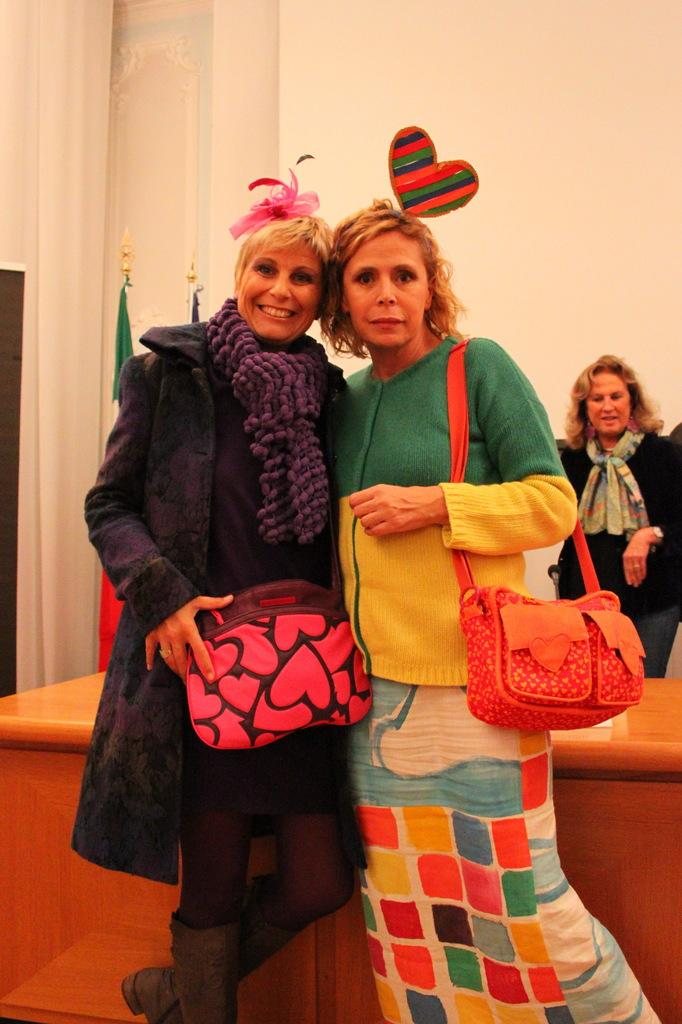How many women are present in the image? There are two women in the image. What are the women holding? The women are holding bags. Can you describe the facial expression of one of the women? One of the women is smiling. What can be seen in the background of the image? There are flags, a table, another woman, and a wall in the background of the image. What type of drum is being played by the woman's aunt in the image? There is no aunt or drum present in the image. 